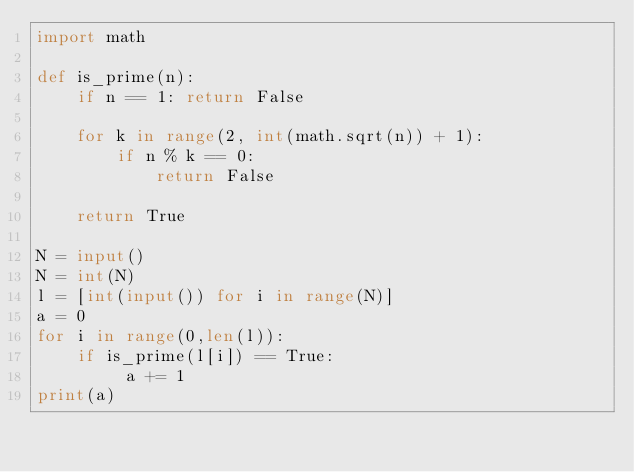Convert code to text. <code><loc_0><loc_0><loc_500><loc_500><_Python_>import math

def is_prime(n):
    if n == 1: return False

    for k in range(2, int(math.sqrt(n)) + 1):
        if n % k == 0:
            return False

    return True

N = input()
N = int(N)
l = [int(input()) for i in range(N)]
a = 0
for i in range(0,len(l)):
    if is_prime(l[i]) == True:
         a += 1
print(a)



</code> 